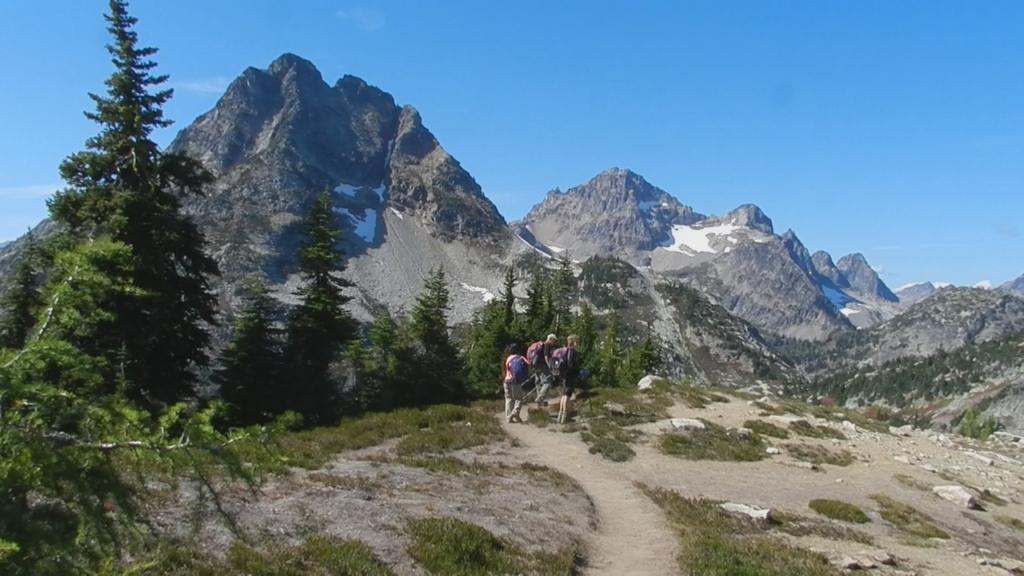What are the people in the image doing? There are persons walking in the center of the image. What can be seen in the distance behind the people? There is a mountain and trees in the background of the image. What type of vegetation is present on the ground in the image? There is grass on the ground in the image. Can you tell me how many chickens are following the persons in the image? There are no chickens present in the image; it only features persons walking and the background setting. 